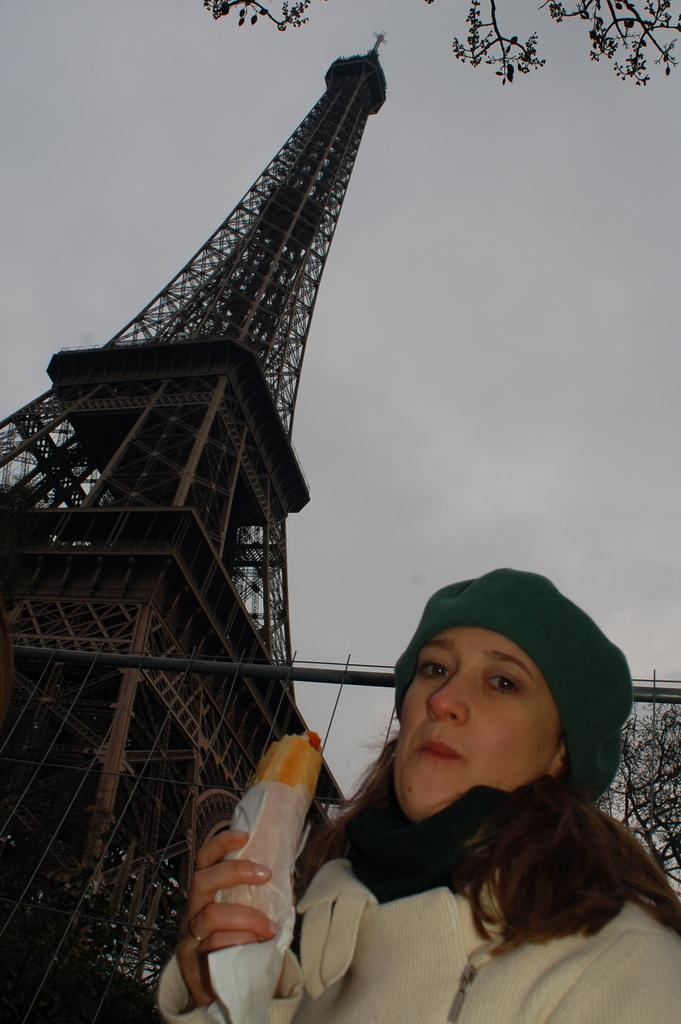In one or two sentences, can you explain what this image depicts? In the picture I can see a woman in the right corner holding an edible in her hand and there is an Eiffel tower in the left corner. 